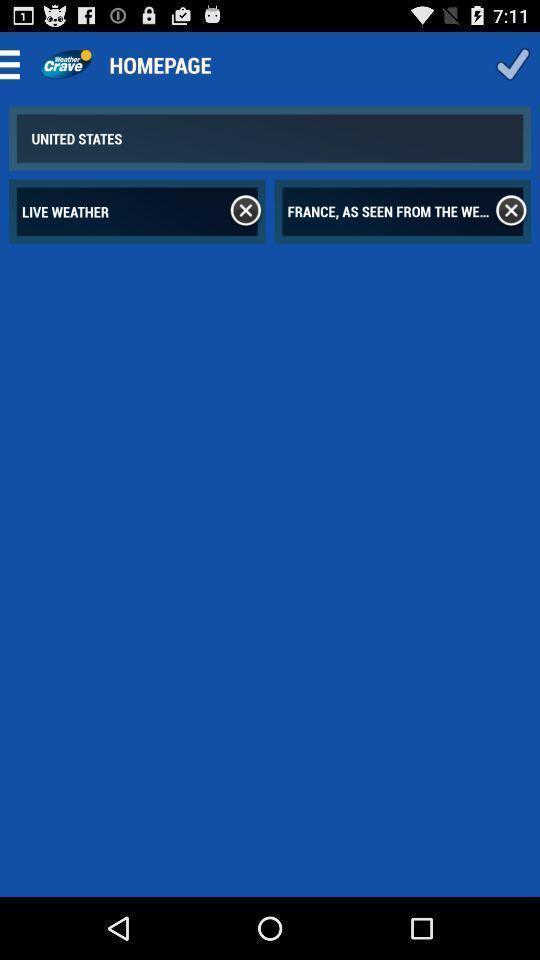Tell me about the visual elements in this screen capture. Page displaying home page. 